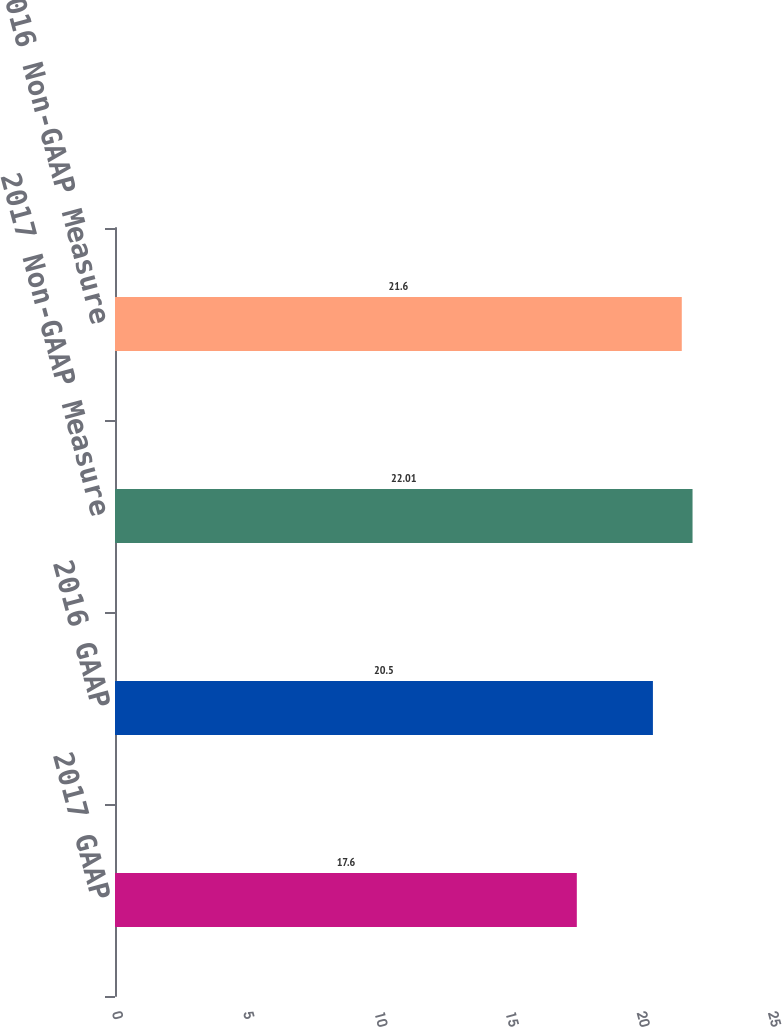<chart> <loc_0><loc_0><loc_500><loc_500><bar_chart><fcel>2017 GAAP<fcel>2016 GAAP<fcel>2017 Non-GAAP Measure<fcel>2016 Non-GAAP Measure<nl><fcel>17.6<fcel>20.5<fcel>22.01<fcel>21.6<nl></chart> 